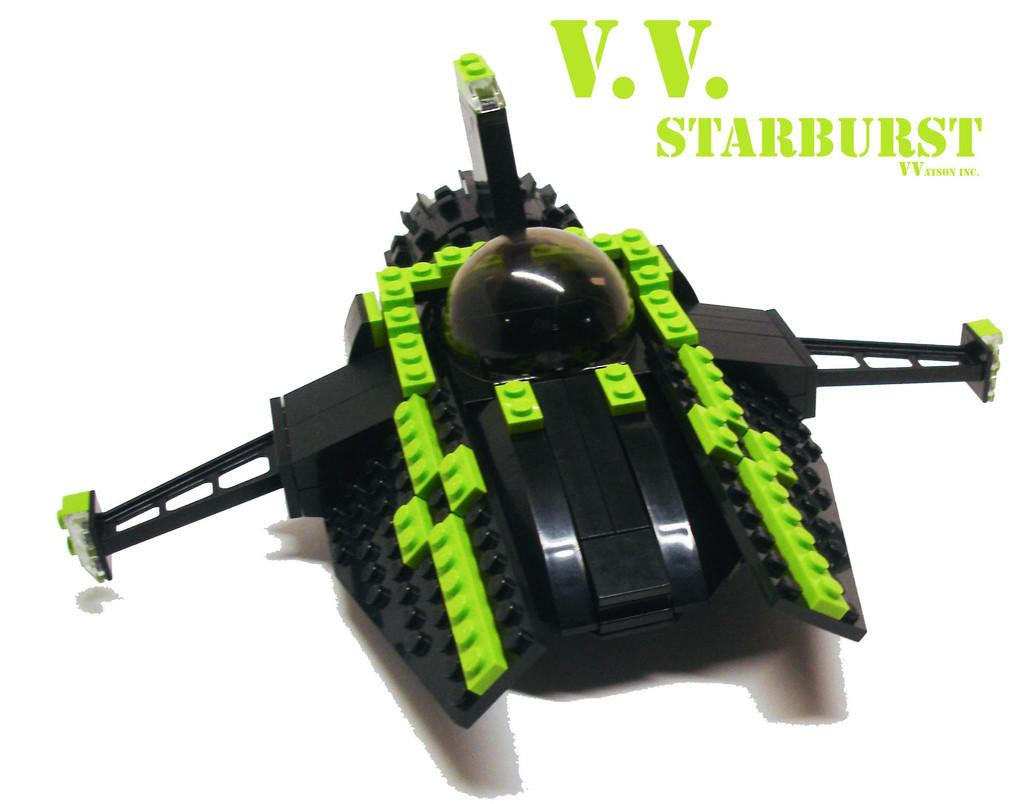What type of object is in the image? There is a toy in the image. What colors can be seen on the toy? The toy has black and green colors. What is the color of the surface the toy is placed on? The toy is on a white surface. What else can be seen in the image besides the toy? There is text visible in the image. Are there any dinosaurs visible in the image? No, there are no dinosaurs present in the image. How does the light affect the appearance of the toy in the image? The provided facts do not mention any light source or its effect on the toy's appearance, so we cannot answer this question based on the given information. 